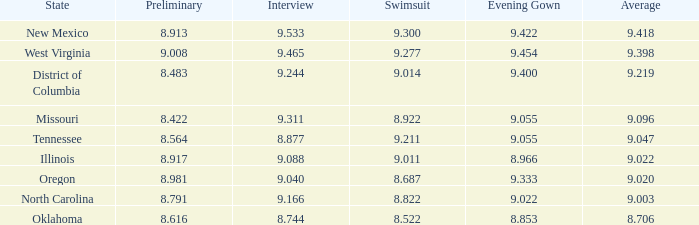Name the swuinsuit for oregon 8.687. 